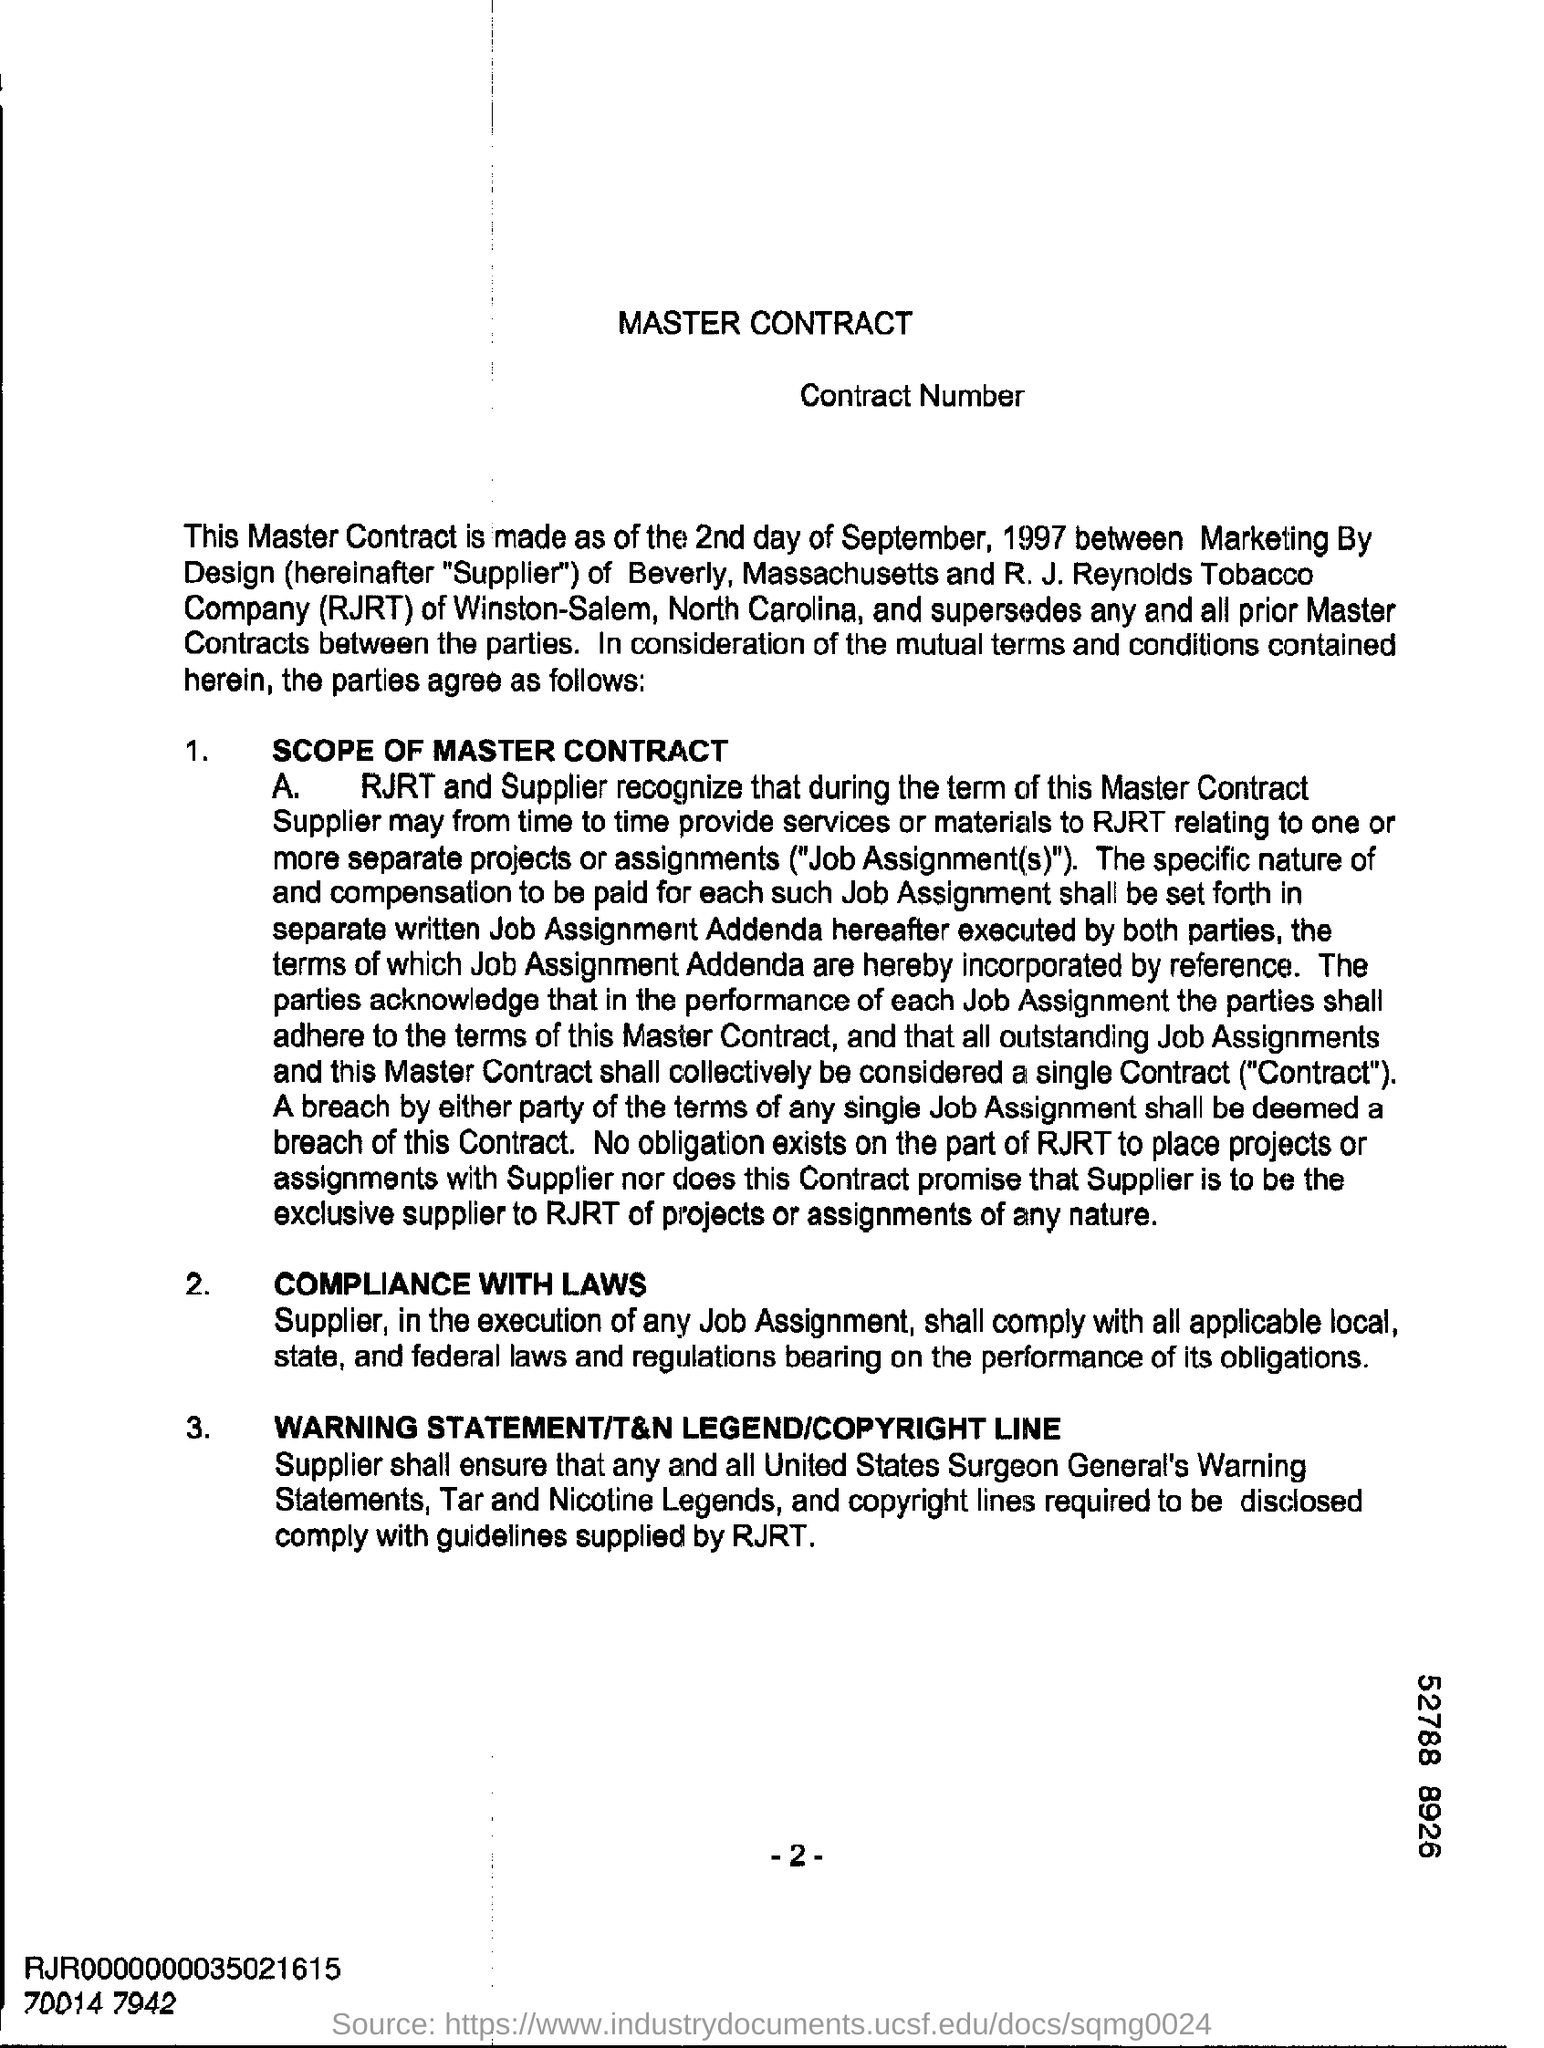What is the heading at top of the page ?
Provide a short and direct response. Master Contract. What is the number at bottom of the page ?
Give a very brief answer. -2-. 